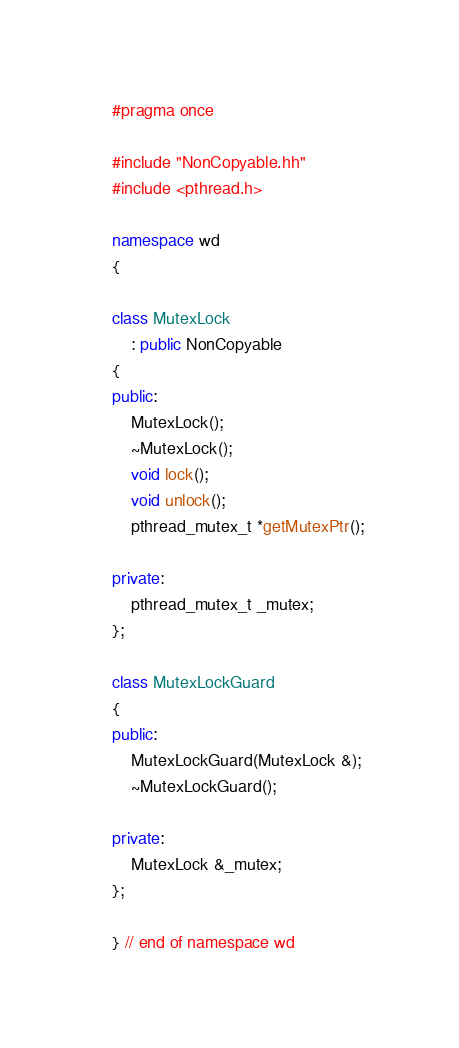Convert code to text. <code><loc_0><loc_0><loc_500><loc_500><_C++_>#pragma once

#include "NonCopyable.hh"
#include <pthread.h>

namespace wd
{

class MutexLock
    : public NonCopyable
{
public:
    MutexLock();
    ~MutexLock();
    void lock();
    void unlock();
    pthread_mutex_t *getMutexPtr();

private:
    pthread_mutex_t _mutex;
};

class MutexLockGuard
{
public:
    MutexLockGuard(MutexLock &);
    ~MutexLockGuard();

private:
    MutexLock &_mutex;
};

} // end of namespace wd</code> 